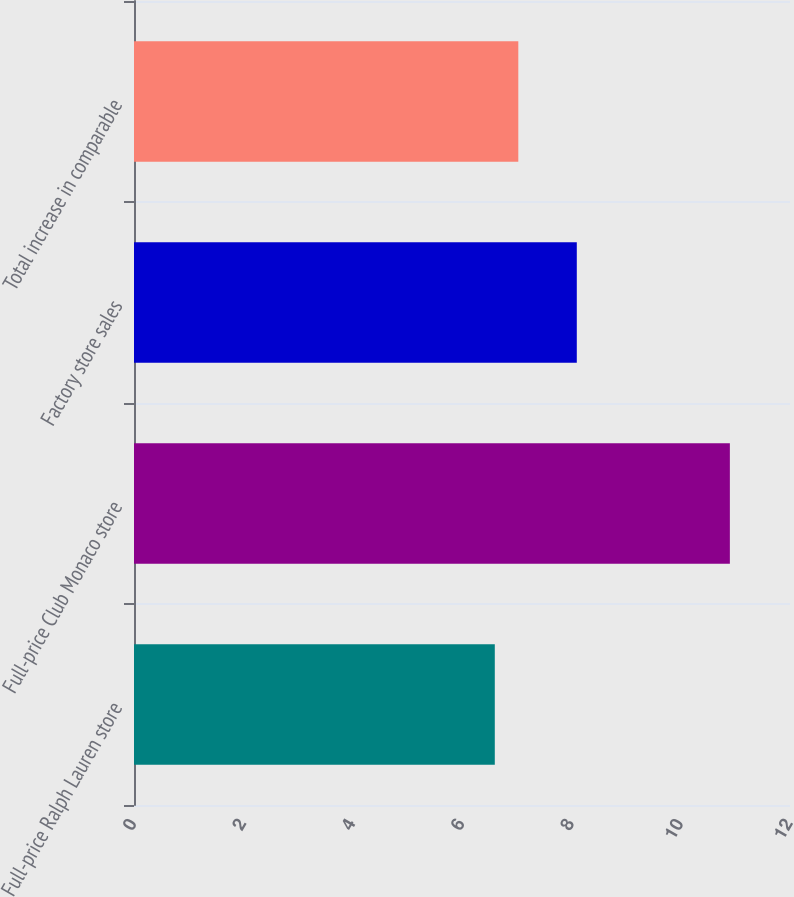Convert chart. <chart><loc_0><loc_0><loc_500><loc_500><bar_chart><fcel>Full-price Ralph Lauren store<fcel>Full-price Club Monaco store<fcel>Factory store sales<fcel>Total increase in comparable<nl><fcel>6.6<fcel>10.9<fcel>8.1<fcel>7.03<nl></chart> 